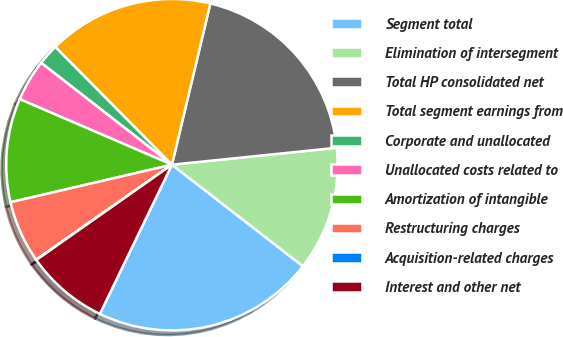<chart> <loc_0><loc_0><loc_500><loc_500><pie_chart><fcel>Segment total<fcel>Elimination of intersegment<fcel>Total HP consolidated net<fcel>Total segment earnings from<fcel>Corporate and unallocated<fcel>Unallocated costs related to<fcel>Amortization of intangible<fcel>Restructuring charges<fcel>Acquisition-related charges<fcel>Interest and other net<nl><fcel>21.67%<fcel>12.12%<fcel>19.65%<fcel>16.15%<fcel>2.04%<fcel>4.06%<fcel>10.11%<fcel>6.08%<fcel>0.03%<fcel>8.09%<nl></chart> 